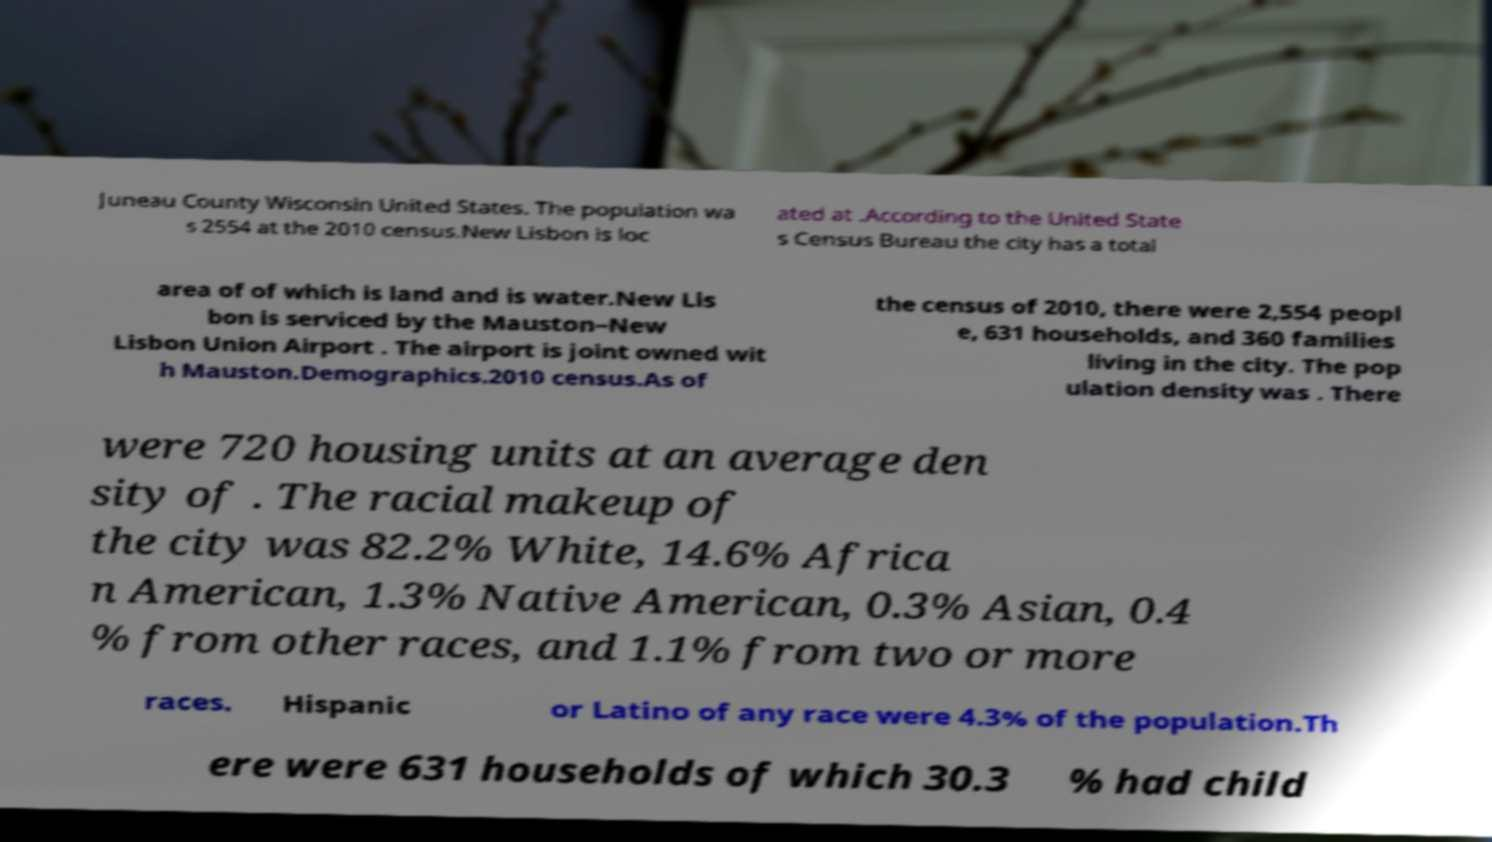For documentation purposes, I need the text within this image transcribed. Could you provide that? Juneau County Wisconsin United States. The population wa s 2554 at the 2010 census.New Lisbon is loc ated at .According to the United State s Census Bureau the city has a total area of of which is land and is water.New Lis bon is serviced by the Mauston–New Lisbon Union Airport . The airport is joint owned wit h Mauston.Demographics.2010 census.As of the census of 2010, there were 2,554 peopl e, 631 households, and 360 families living in the city. The pop ulation density was . There were 720 housing units at an average den sity of . The racial makeup of the city was 82.2% White, 14.6% Africa n American, 1.3% Native American, 0.3% Asian, 0.4 % from other races, and 1.1% from two or more races. Hispanic or Latino of any race were 4.3% of the population.Th ere were 631 households of which 30.3 % had child 